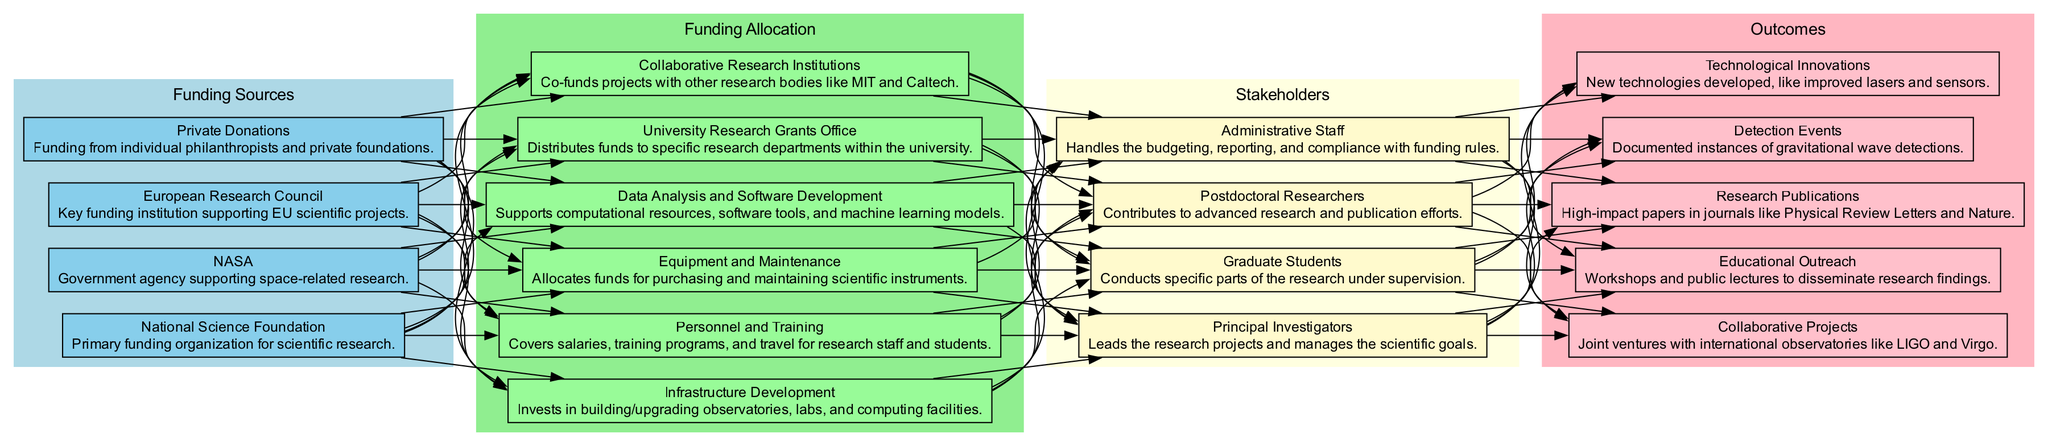What are the sources of funding listed in the diagram? The diagram lists four funding sources: National Science Foundation, NASA, European Research Council, and Private Donations. These are displayed under the "Funding Sources" section of the diagram.
Answer: National Science Foundation, NASA, European Research Council, Private Donations How many funding allocation categories are identified? The diagram features six categories under "Funding Allocation": University Research Grants Office, Collaborative Research Institutions, Infrastructure Development, Personnel and Training, Equipment and Maintenance, and Data Analysis and Software Development.
Answer: Six Who is responsible for distributing funds within the university? The node labeled "University Research Grants Office" specifies that it is responsible for distributing funds to specific research departments within the university.
Answer: University Research Grants Office Which stakeholders are directly involved in the research? The diagram outlines four key stakeholders: Principal Investigators, Graduate Students, Postdoctoral Researchers, and Administrative Staff. Each plays a specific role in the research project.
Answer: Principal Investigators, Graduate Students, Postdoctoral Researchers, Administrative Staff What outcomes result from the stakeholders' work? The outcomes listed include Research Publications, Detection Events, Technological Innovations, Collaborative Projects, and Educational Outreach. These indicate the successful results of the research efforts documented in the diagram.
Answer: Research Publications, Detection Events, Technological Innovations, Collaborative Projects, Educational Outreach How are funding sources connected to the funding allocation? The diagram illustrates that each funding source has edges leading to multiple funding allocation categories, indicating that funds from each source contribute to various areas of research allocation.
Answer: Through edges connecting funding sources to funding allocation categories Which funding allocations are specifically related to personnel costs? The allocations related to personnel costs are "Personnel and Training" which covers salaries and training programs, and potentially "Equipment and Maintenance" if personnel are involved in equipment upkeep.
Answer: Personnel and Training What funding source supports space-related research? "NASA" is identified as the funding source dedicated to supporting space-related research as presented in the "Funding Sources" section.
Answer: NASA Which outcome relates to collaborative efforts with international observatories? The outcome labeled "Collaborative Projects" explicitly refers to joint ventures with international observatories like LIGO and Virgo, outlined under the "Outcomes" section of the diagram.
Answer: Collaborative Projects 